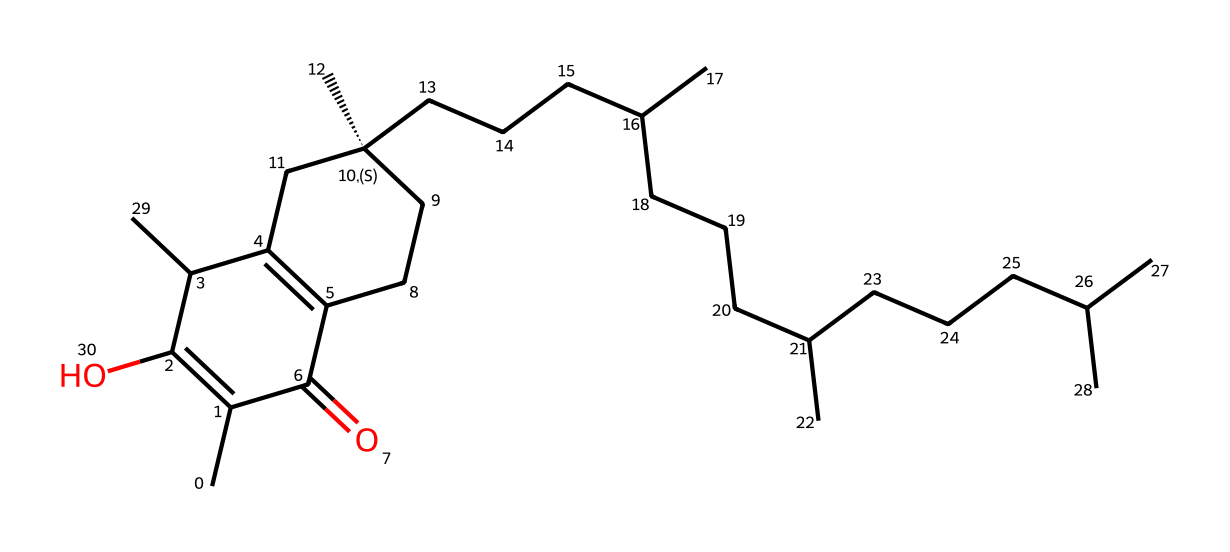What is the name of this chemical? The SMILES representation provided corresponds to tocopherol, which is commonly known as Vitamin E. This is validated by recognizing the molecular structure that matches the known structure of Vitamin E.
Answer: tocopherol How many carbon atoms are present in the structure? To determine the number of carbon atoms, count each carbon in the SMILES. The structure indicates multiple carbon atoms through the detailed representation involving both chain and cyclic components. After counting, the total reaches 30.
Answer: 30 Does this compound contain any oxygen atoms? The structure includes a functional group indicated by the presence of oxygen in the molecular framework, specifically part of the alcohol functional group. In this case, there are two oxygen atoms visible.
Answer: 2 What type of vitamin is tocopherol classified as? Tocopherol, commonly known for being a fat-soluble vitamin, belongs to the class of vitamins known as Vitamin E. This classification is reinforced by its biochemical functions and solubility properties.
Answer: fat-soluble What is the molecular formula of Vitamin E? By analyzing the SMILES representation and counting the atoms, it can be concluded that the molecular formula for tocopherol is C30H50O2, reflecting its composition in terms of carbon, hydrogen, and oxygen atoms.
Answer: C30H50O2 What is the number of double bonds present in this chemical? To find the number of double bonds, evaluate the connections in the structure provided by the SMILES. Recognizing double bond notations in the layout yields a total of 4 double bonds upon analysis.
Answer: 4 Which part of this chemical is responsible for its antioxidant properties? The benzene ring and the hydroxyl group within the structure contribute to the antioxidant properties of tocopherol. These features are crucial for neutralizing free radicals, thus determining its role as an antioxidant.
Answer: benzene ring and hydroxyl group 